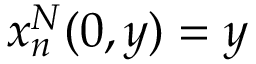Convert formula to latex. <formula><loc_0><loc_0><loc_500><loc_500>x _ { n } ^ { N } ( 0 , y ) = y</formula> 